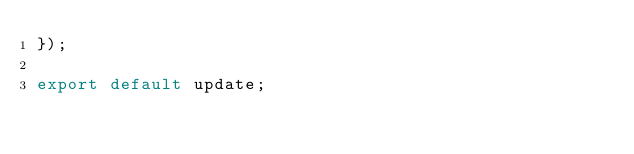<code> <loc_0><loc_0><loc_500><loc_500><_JavaScript_>});

export default update;
</code> 